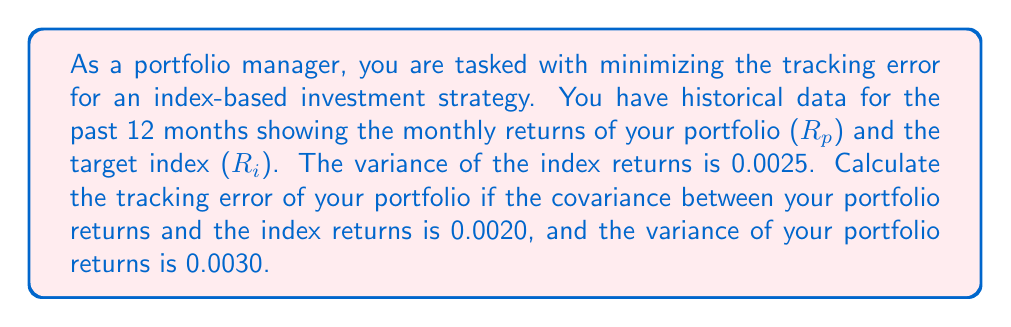Help me with this question. To solve this problem, we need to understand the concept of tracking error and its calculation:

1. Tracking error is a measure of how closely a portfolio follows the index it is intended to track. It is typically expressed as the standard deviation of the difference between the portfolio and index returns.

2. The formula for tracking error (TE) is:

   $$TE = \sqrt{Var(R_p - R_i)}$$

   where $R_p$ is the portfolio return and $R_i$ is the index return.

3. We can expand this formula using the properties of variance:

   $$TE = \sqrt{Var(R_p) + Var(R_i) - 2Cov(R_p, R_i)}$$

4. We are given the following information:
   - $Var(R_i) = 0.0025$
   - $Var(R_p) = 0.0030$
   - $Cov(R_p, R_i) = 0.0020$

5. Let's substitute these values into our formula:

   $$TE = \sqrt{0.0030 + 0.0025 - 2(0.0020)}$$

6. Simplify:
   $$TE = \sqrt{0.0055 - 0.0040}$$
   $$TE = \sqrt{0.0015}$$

7. Calculate the square root:
   $$TE \approx 0.0387$$

8. Convert to percentage:
   $$TE \approx 3.87\%$$

This means that the portfolio's returns deviate from the index's returns by approximately 3.87% on average.
Answer: The tracking error of the portfolio is approximately 3.87%. 